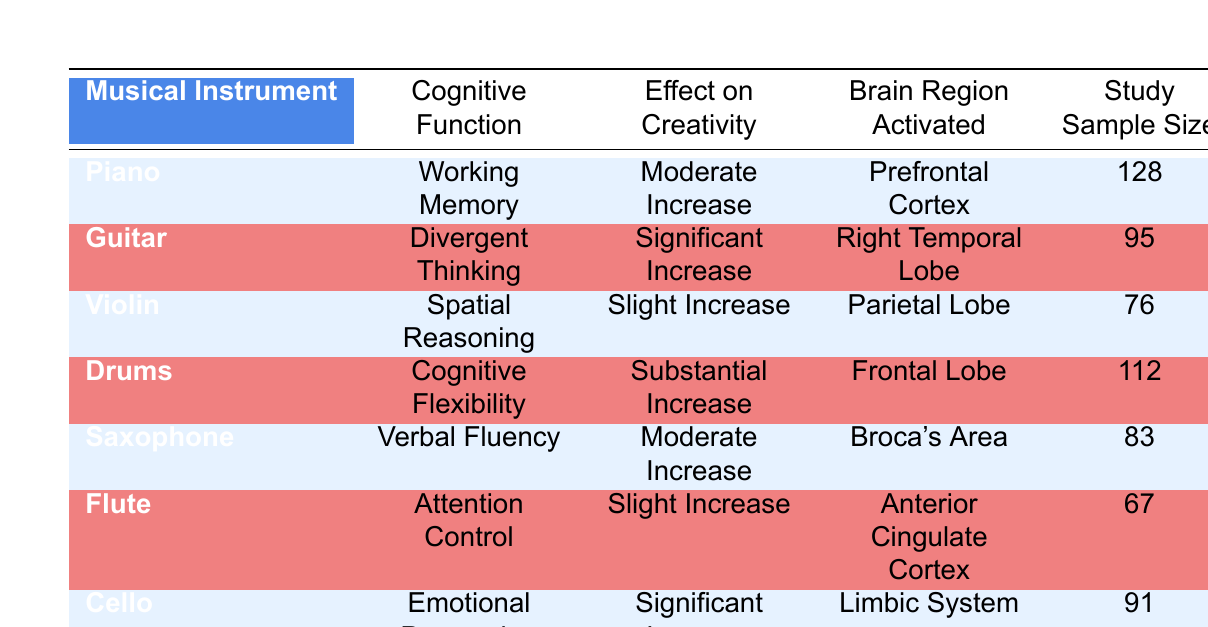What is the effect on creativity of playing the guitar? The table indicates that playing the guitar results in a "Significant Increase" in creativity.
Answer: Significant Increase Which cognitive function is associated with the piano? According to the table, the cognitive function associated with the piano is "Working Memory."
Answer: Working Memory How many participants were in the study that examined the effects of the flute? The table shows the study sample size for the flute is 67 participants.
Answer: 67 Which instrument is linked to the greatest effect on cognitive flexibility? The table shows that the drums have a "Substantial Increase" in cognitive flexibility, indicating it links to the greatest effect.
Answer: Drums Is the emotional processing effect higher for the cello than for the violin? The table states that the cello has a "Significant Increase" in emotional processing while the violin has a "Slight Increase," confirming that the effect is indeed higher for the cello.
Answer: Yes What is the average study sample size for all instruments listed? The sample sizes for each instrument are 128, 95, 76, 112, 83, 67, and 91. Summing these gives 128 + 95 + 76 + 112 + 83 + 67 + 91 = 752. There are 7 instruments, so the average sample size is 752 / 7 = approximately 107.43.
Answer: Approximately 107.43 Which cognitive functions show a "Moderate Increase" in creativity? The table lists two cognitive functions that show a "Moderate Increase": "Working Memory" (Piano) and "Verbal Fluency" (Saxophone).
Answer: Working Memory and Verbal Fluency How many cognitive functions have a slight increase in effect on creativity? According to the table, both the violin (Spatial Reasoning) and the flute (Attention Control) have a "Slight Increase," totaling 2 cognitive functions.
Answer: 2 Is it true that playing the drums activates the Frontal Lobe? Yes, the table confirms that playing the drums activates the Frontal Lobe, which is mentioned in connection to the substantial increase in cognitive flexibility.
Answer: Yes 